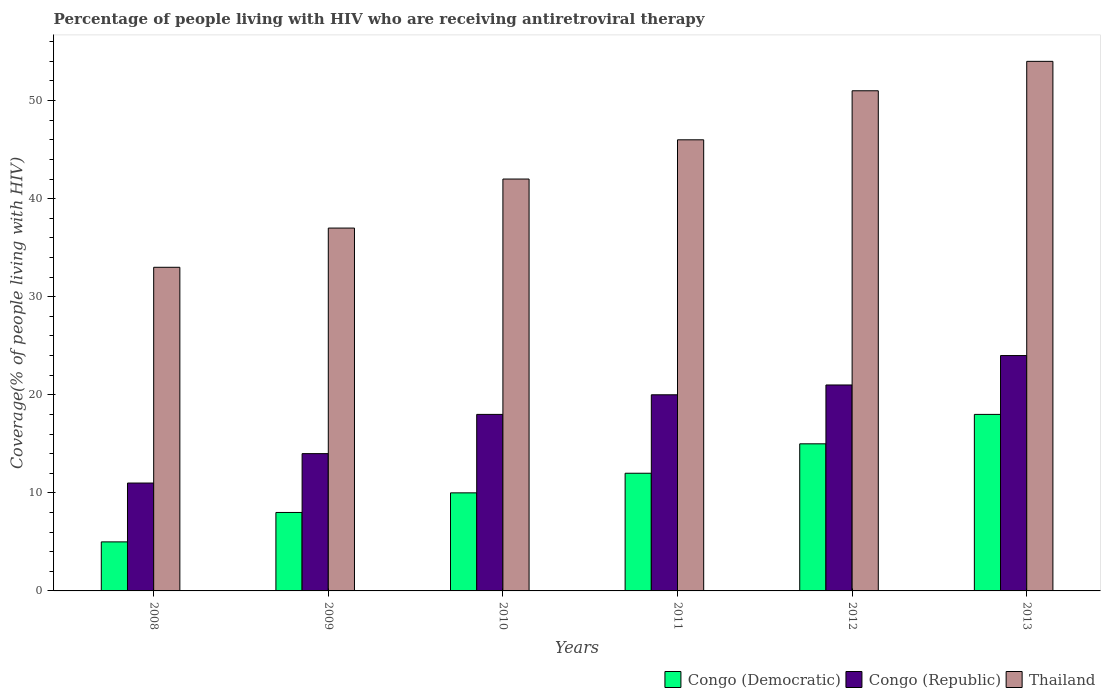What is the percentage of the HIV infected people who are receiving antiretroviral therapy in Congo (Republic) in 2011?
Your answer should be compact. 20. Across all years, what is the maximum percentage of the HIV infected people who are receiving antiretroviral therapy in Thailand?
Make the answer very short. 54. Across all years, what is the minimum percentage of the HIV infected people who are receiving antiretroviral therapy in Congo (Republic)?
Offer a terse response. 11. In which year was the percentage of the HIV infected people who are receiving antiretroviral therapy in Congo (Republic) maximum?
Offer a terse response. 2013. What is the total percentage of the HIV infected people who are receiving antiretroviral therapy in Congo (Republic) in the graph?
Offer a very short reply. 108. What is the difference between the percentage of the HIV infected people who are receiving antiretroviral therapy in Congo (Democratic) in 2009 and that in 2011?
Your answer should be compact. -4. What is the difference between the percentage of the HIV infected people who are receiving antiretroviral therapy in Congo (Democratic) in 2008 and the percentage of the HIV infected people who are receiving antiretroviral therapy in Thailand in 2012?
Your answer should be compact. -46. What is the average percentage of the HIV infected people who are receiving antiretroviral therapy in Congo (Democratic) per year?
Offer a terse response. 11.33. In the year 2012, what is the difference between the percentage of the HIV infected people who are receiving antiretroviral therapy in Congo (Democratic) and percentage of the HIV infected people who are receiving antiretroviral therapy in Congo (Republic)?
Keep it short and to the point. -6. In how many years, is the percentage of the HIV infected people who are receiving antiretroviral therapy in Congo (Republic) greater than 4 %?
Your answer should be compact. 6. What is the ratio of the percentage of the HIV infected people who are receiving antiretroviral therapy in Congo (Republic) in 2011 to that in 2013?
Keep it short and to the point. 0.83. Is the difference between the percentage of the HIV infected people who are receiving antiretroviral therapy in Congo (Democratic) in 2008 and 2012 greater than the difference between the percentage of the HIV infected people who are receiving antiretroviral therapy in Congo (Republic) in 2008 and 2012?
Your response must be concise. No. What is the difference between the highest and the lowest percentage of the HIV infected people who are receiving antiretroviral therapy in Thailand?
Your answer should be very brief. 21. What does the 1st bar from the left in 2010 represents?
Keep it short and to the point. Congo (Democratic). What does the 3rd bar from the right in 2009 represents?
Make the answer very short. Congo (Democratic). Are all the bars in the graph horizontal?
Make the answer very short. No. How many years are there in the graph?
Your answer should be compact. 6. Does the graph contain any zero values?
Give a very brief answer. No. Where does the legend appear in the graph?
Provide a succinct answer. Bottom right. How many legend labels are there?
Offer a very short reply. 3. How are the legend labels stacked?
Provide a succinct answer. Horizontal. What is the title of the graph?
Ensure brevity in your answer.  Percentage of people living with HIV who are receiving antiretroviral therapy. Does "OECD members" appear as one of the legend labels in the graph?
Provide a succinct answer. No. What is the label or title of the Y-axis?
Offer a terse response. Coverage(% of people living with HIV). What is the Coverage(% of people living with HIV) in Congo (Democratic) in 2008?
Offer a very short reply. 5. What is the Coverage(% of people living with HIV) in Congo (Republic) in 2008?
Offer a terse response. 11. What is the Coverage(% of people living with HIV) in Congo (Republic) in 2009?
Offer a very short reply. 14. What is the Coverage(% of people living with HIV) in Congo (Republic) in 2011?
Your response must be concise. 20. What is the Coverage(% of people living with HIV) of Thailand in 2012?
Offer a very short reply. 51. What is the Coverage(% of people living with HIV) in Congo (Democratic) in 2013?
Your response must be concise. 18. Across all years, what is the maximum Coverage(% of people living with HIV) of Congo (Democratic)?
Provide a succinct answer. 18. What is the total Coverage(% of people living with HIV) of Congo (Republic) in the graph?
Give a very brief answer. 108. What is the total Coverage(% of people living with HIV) of Thailand in the graph?
Your answer should be very brief. 263. What is the difference between the Coverage(% of people living with HIV) in Congo (Republic) in 2008 and that in 2010?
Offer a very short reply. -7. What is the difference between the Coverage(% of people living with HIV) of Congo (Republic) in 2008 and that in 2012?
Give a very brief answer. -10. What is the difference between the Coverage(% of people living with HIV) of Congo (Democratic) in 2008 and that in 2013?
Your answer should be compact. -13. What is the difference between the Coverage(% of people living with HIV) in Congo (Republic) in 2008 and that in 2013?
Ensure brevity in your answer.  -13. What is the difference between the Coverage(% of people living with HIV) in Congo (Republic) in 2009 and that in 2010?
Provide a succinct answer. -4. What is the difference between the Coverage(% of people living with HIV) in Thailand in 2009 and that in 2010?
Provide a short and direct response. -5. What is the difference between the Coverage(% of people living with HIV) of Congo (Democratic) in 2009 and that in 2011?
Provide a succinct answer. -4. What is the difference between the Coverage(% of people living with HIV) in Thailand in 2009 and that in 2011?
Provide a short and direct response. -9. What is the difference between the Coverage(% of people living with HIV) in Thailand in 2009 and that in 2012?
Your answer should be compact. -14. What is the difference between the Coverage(% of people living with HIV) in Thailand in 2009 and that in 2013?
Provide a succinct answer. -17. What is the difference between the Coverage(% of people living with HIV) in Congo (Democratic) in 2010 and that in 2012?
Your response must be concise. -5. What is the difference between the Coverage(% of people living with HIV) in Congo (Republic) in 2010 and that in 2012?
Provide a short and direct response. -3. What is the difference between the Coverage(% of people living with HIV) in Congo (Democratic) in 2011 and that in 2012?
Your answer should be compact. -3. What is the difference between the Coverage(% of people living with HIV) of Thailand in 2011 and that in 2013?
Your response must be concise. -8. What is the difference between the Coverage(% of people living with HIV) in Congo (Democratic) in 2012 and that in 2013?
Ensure brevity in your answer.  -3. What is the difference between the Coverage(% of people living with HIV) of Congo (Democratic) in 2008 and the Coverage(% of people living with HIV) of Thailand in 2009?
Give a very brief answer. -32. What is the difference between the Coverage(% of people living with HIV) of Congo (Democratic) in 2008 and the Coverage(% of people living with HIV) of Congo (Republic) in 2010?
Ensure brevity in your answer.  -13. What is the difference between the Coverage(% of people living with HIV) of Congo (Democratic) in 2008 and the Coverage(% of people living with HIV) of Thailand in 2010?
Offer a terse response. -37. What is the difference between the Coverage(% of people living with HIV) of Congo (Republic) in 2008 and the Coverage(% of people living with HIV) of Thailand in 2010?
Offer a very short reply. -31. What is the difference between the Coverage(% of people living with HIV) in Congo (Democratic) in 2008 and the Coverage(% of people living with HIV) in Thailand in 2011?
Your answer should be compact. -41. What is the difference between the Coverage(% of people living with HIV) of Congo (Republic) in 2008 and the Coverage(% of people living with HIV) of Thailand in 2011?
Offer a terse response. -35. What is the difference between the Coverage(% of people living with HIV) of Congo (Democratic) in 2008 and the Coverage(% of people living with HIV) of Thailand in 2012?
Ensure brevity in your answer.  -46. What is the difference between the Coverage(% of people living with HIV) in Congo (Republic) in 2008 and the Coverage(% of people living with HIV) in Thailand in 2012?
Your response must be concise. -40. What is the difference between the Coverage(% of people living with HIV) in Congo (Democratic) in 2008 and the Coverage(% of people living with HIV) in Thailand in 2013?
Keep it short and to the point. -49. What is the difference between the Coverage(% of people living with HIV) in Congo (Republic) in 2008 and the Coverage(% of people living with HIV) in Thailand in 2013?
Ensure brevity in your answer.  -43. What is the difference between the Coverage(% of people living with HIV) in Congo (Democratic) in 2009 and the Coverage(% of people living with HIV) in Thailand in 2010?
Offer a very short reply. -34. What is the difference between the Coverage(% of people living with HIV) in Congo (Democratic) in 2009 and the Coverage(% of people living with HIV) in Congo (Republic) in 2011?
Keep it short and to the point. -12. What is the difference between the Coverage(% of people living with HIV) of Congo (Democratic) in 2009 and the Coverage(% of people living with HIV) of Thailand in 2011?
Your response must be concise. -38. What is the difference between the Coverage(% of people living with HIV) in Congo (Republic) in 2009 and the Coverage(% of people living with HIV) in Thailand in 2011?
Your answer should be compact. -32. What is the difference between the Coverage(% of people living with HIV) in Congo (Democratic) in 2009 and the Coverage(% of people living with HIV) in Thailand in 2012?
Give a very brief answer. -43. What is the difference between the Coverage(% of people living with HIV) of Congo (Republic) in 2009 and the Coverage(% of people living with HIV) of Thailand in 2012?
Offer a very short reply. -37. What is the difference between the Coverage(% of people living with HIV) in Congo (Democratic) in 2009 and the Coverage(% of people living with HIV) in Thailand in 2013?
Offer a very short reply. -46. What is the difference between the Coverage(% of people living with HIV) in Congo (Democratic) in 2010 and the Coverage(% of people living with HIV) in Congo (Republic) in 2011?
Keep it short and to the point. -10. What is the difference between the Coverage(% of people living with HIV) in Congo (Democratic) in 2010 and the Coverage(% of people living with HIV) in Thailand in 2011?
Your answer should be compact. -36. What is the difference between the Coverage(% of people living with HIV) of Congo (Republic) in 2010 and the Coverage(% of people living with HIV) of Thailand in 2011?
Keep it short and to the point. -28. What is the difference between the Coverage(% of people living with HIV) in Congo (Democratic) in 2010 and the Coverage(% of people living with HIV) in Congo (Republic) in 2012?
Ensure brevity in your answer.  -11. What is the difference between the Coverage(% of people living with HIV) of Congo (Democratic) in 2010 and the Coverage(% of people living with HIV) of Thailand in 2012?
Your answer should be compact. -41. What is the difference between the Coverage(% of people living with HIV) in Congo (Republic) in 2010 and the Coverage(% of people living with HIV) in Thailand in 2012?
Ensure brevity in your answer.  -33. What is the difference between the Coverage(% of people living with HIV) in Congo (Democratic) in 2010 and the Coverage(% of people living with HIV) in Thailand in 2013?
Give a very brief answer. -44. What is the difference between the Coverage(% of people living with HIV) in Congo (Republic) in 2010 and the Coverage(% of people living with HIV) in Thailand in 2013?
Ensure brevity in your answer.  -36. What is the difference between the Coverage(% of people living with HIV) in Congo (Democratic) in 2011 and the Coverage(% of people living with HIV) in Congo (Republic) in 2012?
Provide a short and direct response. -9. What is the difference between the Coverage(% of people living with HIV) in Congo (Democratic) in 2011 and the Coverage(% of people living with HIV) in Thailand in 2012?
Provide a short and direct response. -39. What is the difference between the Coverage(% of people living with HIV) in Congo (Republic) in 2011 and the Coverage(% of people living with HIV) in Thailand in 2012?
Provide a succinct answer. -31. What is the difference between the Coverage(% of people living with HIV) in Congo (Democratic) in 2011 and the Coverage(% of people living with HIV) in Congo (Republic) in 2013?
Keep it short and to the point. -12. What is the difference between the Coverage(% of people living with HIV) of Congo (Democratic) in 2011 and the Coverage(% of people living with HIV) of Thailand in 2013?
Provide a succinct answer. -42. What is the difference between the Coverage(% of people living with HIV) in Congo (Republic) in 2011 and the Coverage(% of people living with HIV) in Thailand in 2013?
Your response must be concise. -34. What is the difference between the Coverage(% of people living with HIV) in Congo (Democratic) in 2012 and the Coverage(% of people living with HIV) in Thailand in 2013?
Ensure brevity in your answer.  -39. What is the difference between the Coverage(% of people living with HIV) in Congo (Republic) in 2012 and the Coverage(% of people living with HIV) in Thailand in 2013?
Make the answer very short. -33. What is the average Coverage(% of people living with HIV) of Congo (Democratic) per year?
Offer a terse response. 11.33. What is the average Coverage(% of people living with HIV) of Thailand per year?
Make the answer very short. 43.83. In the year 2008, what is the difference between the Coverage(% of people living with HIV) in Congo (Democratic) and Coverage(% of people living with HIV) in Congo (Republic)?
Your answer should be compact. -6. In the year 2008, what is the difference between the Coverage(% of people living with HIV) in Congo (Republic) and Coverage(% of people living with HIV) in Thailand?
Your response must be concise. -22. In the year 2009, what is the difference between the Coverage(% of people living with HIV) in Congo (Democratic) and Coverage(% of people living with HIV) in Congo (Republic)?
Keep it short and to the point. -6. In the year 2009, what is the difference between the Coverage(% of people living with HIV) in Congo (Democratic) and Coverage(% of people living with HIV) in Thailand?
Give a very brief answer. -29. In the year 2010, what is the difference between the Coverage(% of people living with HIV) in Congo (Democratic) and Coverage(% of people living with HIV) in Congo (Republic)?
Offer a terse response. -8. In the year 2010, what is the difference between the Coverage(% of people living with HIV) of Congo (Democratic) and Coverage(% of people living with HIV) of Thailand?
Your response must be concise. -32. In the year 2011, what is the difference between the Coverage(% of people living with HIV) of Congo (Democratic) and Coverage(% of people living with HIV) of Congo (Republic)?
Provide a succinct answer. -8. In the year 2011, what is the difference between the Coverage(% of people living with HIV) of Congo (Democratic) and Coverage(% of people living with HIV) of Thailand?
Offer a terse response. -34. In the year 2012, what is the difference between the Coverage(% of people living with HIV) of Congo (Democratic) and Coverage(% of people living with HIV) of Congo (Republic)?
Provide a short and direct response. -6. In the year 2012, what is the difference between the Coverage(% of people living with HIV) of Congo (Democratic) and Coverage(% of people living with HIV) of Thailand?
Ensure brevity in your answer.  -36. In the year 2012, what is the difference between the Coverage(% of people living with HIV) in Congo (Republic) and Coverage(% of people living with HIV) in Thailand?
Ensure brevity in your answer.  -30. In the year 2013, what is the difference between the Coverage(% of people living with HIV) of Congo (Democratic) and Coverage(% of people living with HIV) of Congo (Republic)?
Provide a succinct answer. -6. In the year 2013, what is the difference between the Coverage(% of people living with HIV) of Congo (Democratic) and Coverage(% of people living with HIV) of Thailand?
Your response must be concise. -36. What is the ratio of the Coverage(% of people living with HIV) of Congo (Democratic) in 2008 to that in 2009?
Make the answer very short. 0.62. What is the ratio of the Coverage(% of people living with HIV) of Congo (Republic) in 2008 to that in 2009?
Your answer should be compact. 0.79. What is the ratio of the Coverage(% of people living with HIV) of Thailand in 2008 to that in 2009?
Your response must be concise. 0.89. What is the ratio of the Coverage(% of people living with HIV) of Congo (Republic) in 2008 to that in 2010?
Give a very brief answer. 0.61. What is the ratio of the Coverage(% of people living with HIV) in Thailand in 2008 to that in 2010?
Keep it short and to the point. 0.79. What is the ratio of the Coverage(% of people living with HIV) in Congo (Democratic) in 2008 to that in 2011?
Offer a terse response. 0.42. What is the ratio of the Coverage(% of people living with HIV) in Congo (Republic) in 2008 to that in 2011?
Provide a succinct answer. 0.55. What is the ratio of the Coverage(% of people living with HIV) in Thailand in 2008 to that in 2011?
Offer a terse response. 0.72. What is the ratio of the Coverage(% of people living with HIV) in Congo (Democratic) in 2008 to that in 2012?
Provide a short and direct response. 0.33. What is the ratio of the Coverage(% of people living with HIV) in Congo (Republic) in 2008 to that in 2012?
Your answer should be very brief. 0.52. What is the ratio of the Coverage(% of people living with HIV) in Thailand in 2008 to that in 2012?
Keep it short and to the point. 0.65. What is the ratio of the Coverage(% of people living with HIV) in Congo (Democratic) in 2008 to that in 2013?
Ensure brevity in your answer.  0.28. What is the ratio of the Coverage(% of people living with HIV) in Congo (Republic) in 2008 to that in 2013?
Give a very brief answer. 0.46. What is the ratio of the Coverage(% of people living with HIV) of Thailand in 2008 to that in 2013?
Your response must be concise. 0.61. What is the ratio of the Coverage(% of people living with HIV) in Congo (Democratic) in 2009 to that in 2010?
Offer a very short reply. 0.8. What is the ratio of the Coverage(% of people living with HIV) of Congo (Republic) in 2009 to that in 2010?
Your response must be concise. 0.78. What is the ratio of the Coverage(% of people living with HIV) of Thailand in 2009 to that in 2010?
Provide a succinct answer. 0.88. What is the ratio of the Coverage(% of people living with HIV) in Congo (Democratic) in 2009 to that in 2011?
Provide a short and direct response. 0.67. What is the ratio of the Coverage(% of people living with HIV) of Thailand in 2009 to that in 2011?
Keep it short and to the point. 0.8. What is the ratio of the Coverage(% of people living with HIV) in Congo (Democratic) in 2009 to that in 2012?
Offer a very short reply. 0.53. What is the ratio of the Coverage(% of people living with HIV) in Thailand in 2009 to that in 2012?
Give a very brief answer. 0.73. What is the ratio of the Coverage(% of people living with HIV) in Congo (Democratic) in 2009 to that in 2013?
Make the answer very short. 0.44. What is the ratio of the Coverage(% of people living with HIV) of Congo (Republic) in 2009 to that in 2013?
Provide a succinct answer. 0.58. What is the ratio of the Coverage(% of people living with HIV) in Thailand in 2009 to that in 2013?
Offer a terse response. 0.69. What is the ratio of the Coverage(% of people living with HIV) in Congo (Republic) in 2010 to that in 2012?
Your answer should be very brief. 0.86. What is the ratio of the Coverage(% of people living with HIV) in Thailand in 2010 to that in 2012?
Ensure brevity in your answer.  0.82. What is the ratio of the Coverage(% of people living with HIV) in Congo (Democratic) in 2010 to that in 2013?
Give a very brief answer. 0.56. What is the ratio of the Coverage(% of people living with HIV) in Congo (Republic) in 2011 to that in 2012?
Offer a terse response. 0.95. What is the ratio of the Coverage(% of people living with HIV) of Thailand in 2011 to that in 2012?
Give a very brief answer. 0.9. What is the ratio of the Coverage(% of people living with HIV) of Thailand in 2011 to that in 2013?
Provide a short and direct response. 0.85. What is the difference between the highest and the second highest Coverage(% of people living with HIV) of Congo (Democratic)?
Your answer should be very brief. 3. What is the difference between the highest and the lowest Coverage(% of people living with HIV) in Congo (Democratic)?
Offer a very short reply. 13. What is the difference between the highest and the lowest Coverage(% of people living with HIV) in Thailand?
Make the answer very short. 21. 